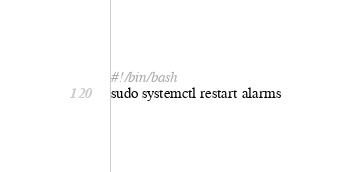Convert code to text. <code><loc_0><loc_0><loc_500><loc_500><_Bash_>#!/bin/bash
sudo systemctl restart alarms
</code> 